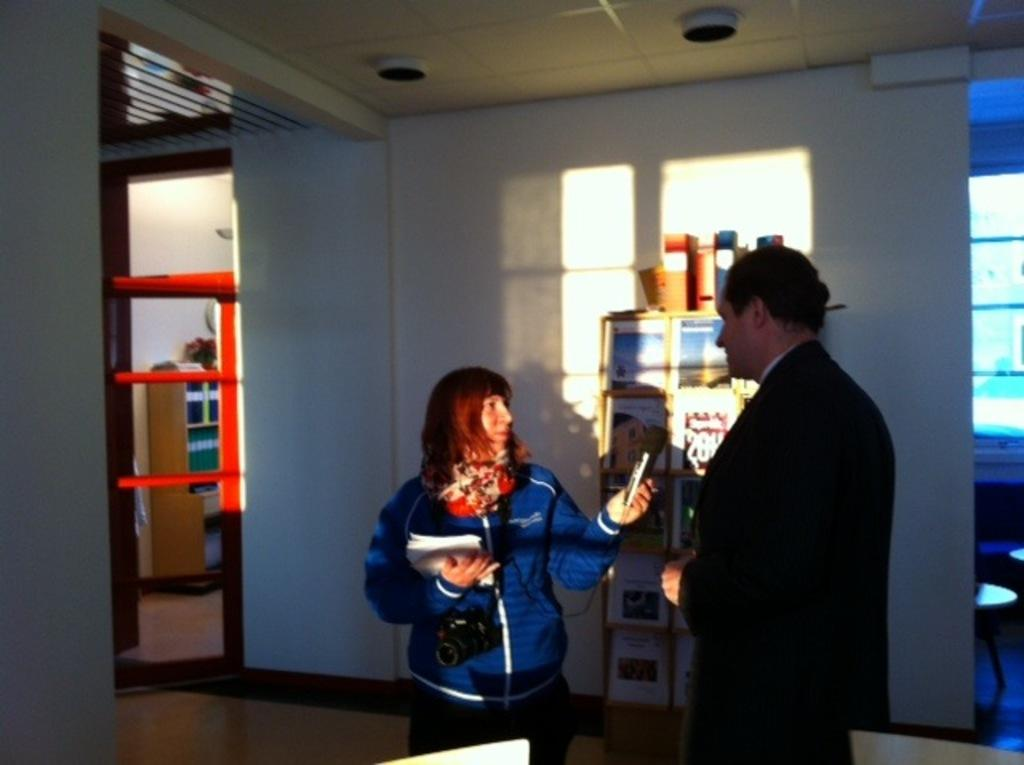How many persons are on the floor in the image? There are two persons on the floor in the image. What are the persons holding? One person is holding papers, another person is holding a camera, and the third person is holding a device. What can be seen in the background of the image? There are frames, a door, objects, chairs, and glasses visible in the background. What is above the persons in the image? There is a ceiling in the image. What type of oatmeal is being served in the image? There is no oatmeal present in the image. What is the title of the book the person is holding in the image? There is no book visible in the image, so it is not possible to determine the title. 